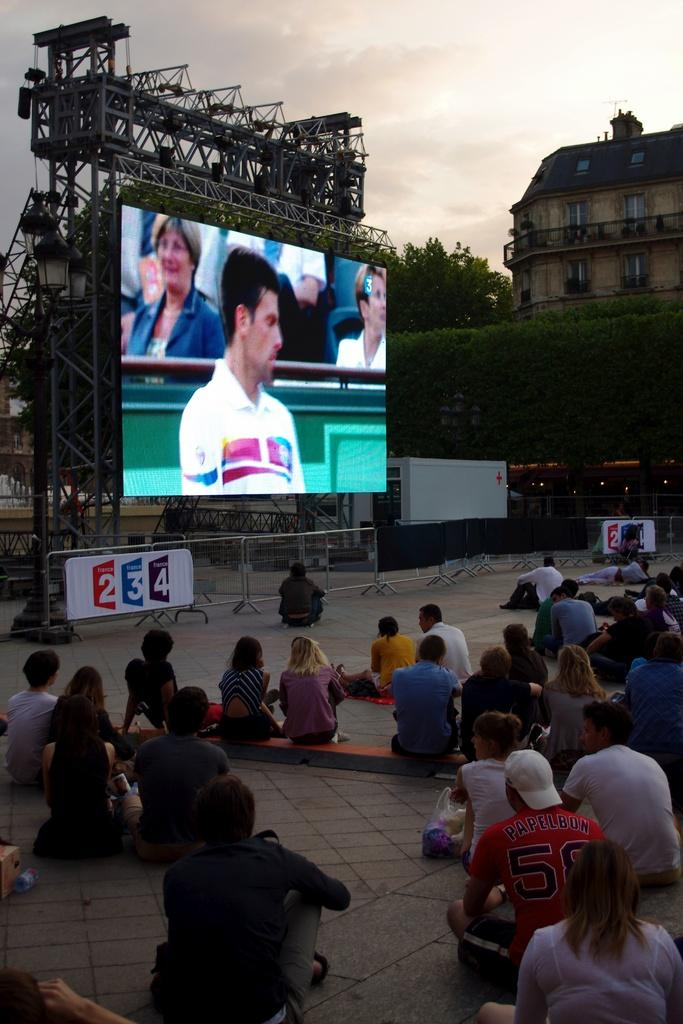<image>
Offer a succinct explanation of the picture presented. A large screen sponsored by France 234 shows a game being played to a crowd sitting around it. 